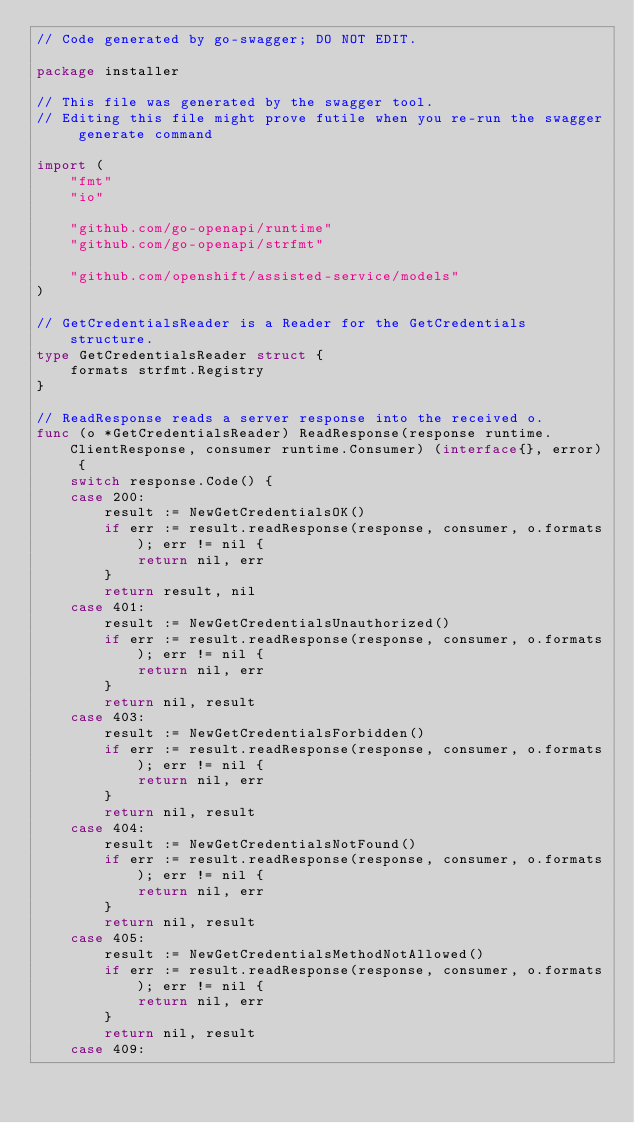Convert code to text. <code><loc_0><loc_0><loc_500><loc_500><_Go_>// Code generated by go-swagger; DO NOT EDIT.

package installer

// This file was generated by the swagger tool.
// Editing this file might prove futile when you re-run the swagger generate command

import (
	"fmt"
	"io"

	"github.com/go-openapi/runtime"
	"github.com/go-openapi/strfmt"

	"github.com/openshift/assisted-service/models"
)

// GetCredentialsReader is a Reader for the GetCredentials structure.
type GetCredentialsReader struct {
	formats strfmt.Registry
}

// ReadResponse reads a server response into the received o.
func (o *GetCredentialsReader) ReadResponse(response runtime.ClientResponse, consumer runtime.Consumer) (interface{}, error) {
	switch response.Code() {
	case 200:
		result := NewGetCredentialsOK()
		if err := result.readResponse(response, consumer, o.formats); err != nil {
			return nil, err
		}
		return result, nil
	case 401:
		result := NewGetCredentialsUnauthorized()
		if err := result.readResponse(response, consumer, o.formats); err != nil {
			return nil, err
		}
		return nil, result
	case 403:
		result := NewGetCredentialsForbidden()
		if err := result.readResponse(response, consumer, o.formats); err != nil {
			return nil, err
		}
		return nil, result
	case 404:
		result := NewGetCredentialsNotFound()
		if err := result.readResponse(response, consumer, o.formats); err != nil {
			return nil, err
		}
		return nil, result
	case 405:
		result := NewGetCredentialsMethodNotAllowed()
		if err := result.readResponse(response, consumer, o.formats); err != nil {
			return nil, err
		}
		return nil, result
	case 409:</code> 